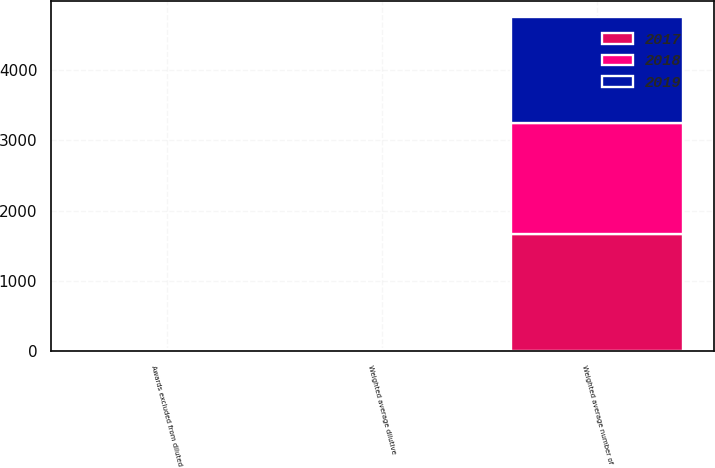<chart> <loc_0><loc_0><loc_500><loc_500><stacked_bar_chart><ecel><fcel>Weighted average number of<fcel>Weighted average dilutive<fcel>Awards excluded from diluted<nl><fcel>2017<fcel>1666<fcel>10<fcel>7<nl><fcel>2019<fcel>1507<fcel>8<fcel>12<nl><fcel>2018<fcel>1578<fcel>10<fcel>10<nl></chart> 